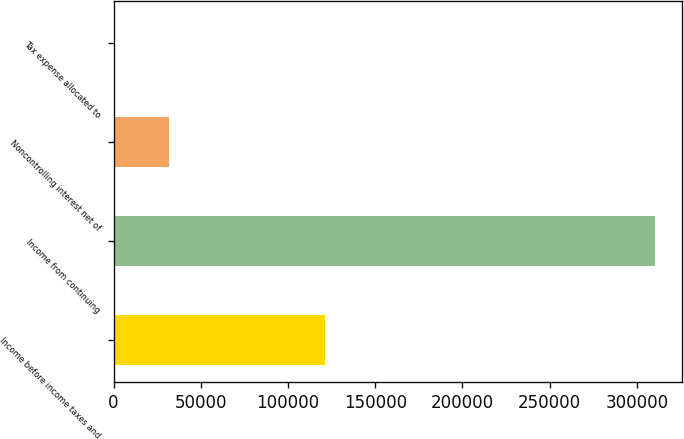<chart> <loc_0><loc_0><loc_500><loc_500><bar_chart><fcel>Income before income taxes and<fcel>Income from continuing<fcel>Noncontrolling interest net of<fcel>Tax expense allocated to<nl><fcel>121273<fcel>310389<fcel>31567.2<fcel>587<nl></chart> 